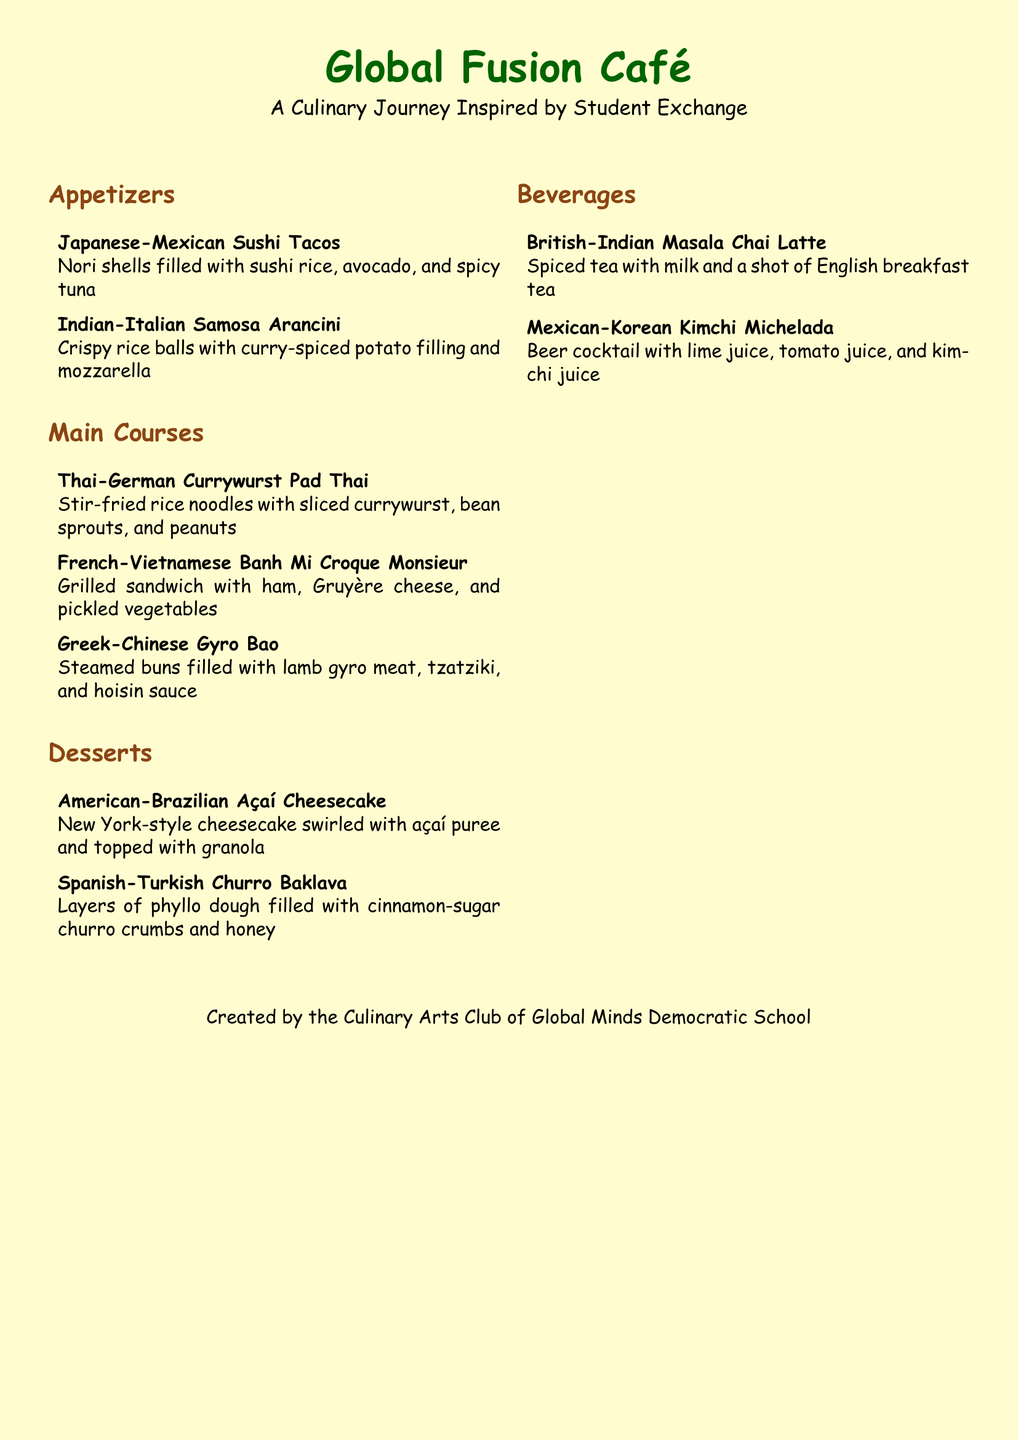What is the name of the restaurant? The name of the restaurant is prominently displayed at the top of the menu.
Answer: Global Fusion Café What type of cuisine does the menu feature? The menu highlights a blend of various cultural influences through its dishes.
Answer: Multicultural fusion Who created the menu? The creator of the menu is mentioned at the bottom of the document.
Answer: Culinary Arts Club of Global Minds Democratic School What is an appetizer that combines Japanese and Mexican cuisine? The menu lists specific examples of dishes blending different cultures.
Answer: Japanese-Mexican Sushi Tacos How many desserts are listed in the menu? The desserts section contains a specific number of items which can be counted.
Answer: 2 What beverage combines British and Indian influences? The beverage section includes drinks that reflect different cultural fusions.
Answer: British-Indian Masala Chai Latte What is a main course that includes German cuisine? The main course section has dishes that feature various culinary traditions.
Answer: Thai-German Currywurst Pad Thai Which dessert includes açaí? The desserts section specifies the ingredients used in each item.
Answer: American-Brazilian Açaí Cheesecake What is included in the French-Vietnamese main course? The ingredients of each main course can be identified from the descriptions.
Answer: Ham, Gruyère cheese, and pickled vegetables 